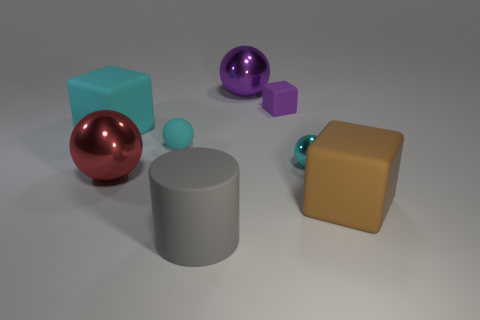Add 2 tiny cyan spheres. How many objects exist? 10 Subtract all cubes. How many objects are left? 5 Subtract all cyan matte things. Subtract all gray rubber cylinders. How many objects are left? 5 Add 6 big shiny spheres. How many big shiny spheres are left? 8 Add 6 small yellow metal things. How many small yellow metal things exist? 6 Subtract 0 green cylinders. How many objects are left? 8 